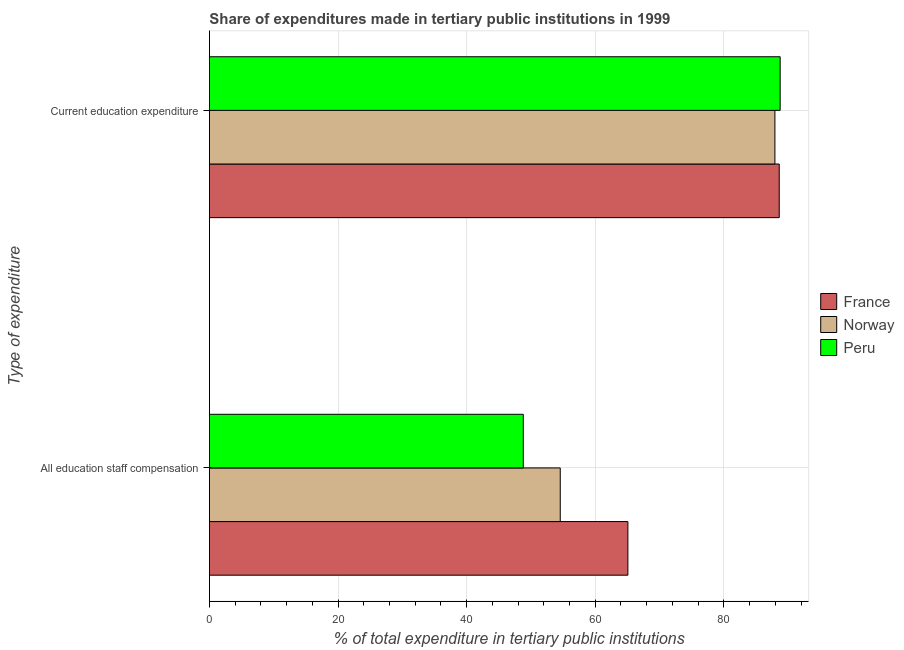Are the number of bars per tick equal to the number of legend labels?
Offer a very short reply. Yes. How many bars are there on the 1st tick from the top?
Provide a short and direct response. 3. What is the label of the 2nd group of bars from the top?
Provide a succinct answer. All education staff compensation. What is the expenditure in staff compensation in Norway?
Ensure brevity in your answer.  54.56. Across all countries, what is the maximum expenditure in education?
Your response must be concise. 88.76. Across all countries, what is the minimum expenditure in education?
Make the answer very short. 87.94. In which country was the expenditure in staff compensation maximum?
Your response must be concise. France. What is the total expenditure in education in the graph?
Your answer should be compact. 265.3. What is the difference between the expenditure in staff compensation in Norway and that in France?
Make the answer very short. -10.52. What is the difference between the expenditure in education in France and the expenditure in staff compensation in Norway?
Offer a very short reply. 34.05. What is the average expenditure in education per country?
Provide a short and direct response. 88.43. What is the difference between the expenditure in staff compensation and expenditure in education in Norway?
Provide a short and direct response. -33.38. What is the ratio of the expenditure in staff compensation in Norway to that in France?
Offer a terse response. 0.84. Is the expenditure in staff compensation in France less than that in Peru?
Provide a short and direct response. No. What does the 2nd bar from the top in All education staff compensation represents?
Offer a terse response. Norway. What does the 1st bar from the bottom in Current education expenditure represents?
Offer a terse response. France. How many bars are there?
Your response must be concise. 6. What is the difference between two consecutive major ticks on the X-axis?
Ensure brevity in your answer.  20. Are the values on the major ticks of X-axis written in scientific E-notation?
Provide a short and direct response. No. Does the graph contain any zero values?
Your answer should be very brief. No. Does the graph contain grids?
Your answer should be compact. Yes. Where does the legend appear in the graph?
Provide a short and direct response. Center right. How many legend labels are there?
Your response must be concise. 3. How are the legend labels stacked?
Ensure brevity in your answer.  Vertical. What is the title of the graph?
Your answer should be very brief. Share of expenditures made in tertiary public institutions in 1999. What is the label or title of the X-axis?
Offer a terse response. % of total expenditure in tertiary public institutions. What is the label or title of the Y-axis?
Keep it short and to the point. Type of expenditure. What is the % of total expenditure in tertiary public institutions of France in All education staff compensation?
Your answer should be very brief. 65.08. What is the % of total expenditure in tertiary public institutions of Norway in All education staff compensation?
Make the answer very short. 54.56. What is the % of total expenditure in tertiary public institutions in Peru in All education staff compensation?
Provide a succinct answer. 48.81. What is the % of total expenditure in tertiary public institutions in France in Current education expenditure?
Provide a succinct answer. 88.61. What is the % of total expenditure in tertiary public institutions in Norway in Current education expenditure?
Give a very brief answer. 87.94. What is the % of total expenditure in tertiary public institutions of Peru in Current education expenditure?
Your answer should be compact. 88.76. Across all Type of expenditure, what is the maximum % of total expenditure in tertiary public institutions of France?
Your answer should be very brief. 88.61. Across all Type of expenditure, what is the maximum % of total expenditure in tertiary public institutions in Norway?
Ensure brevity in your answer.  87.94. Across all Type of expenditure, what is the maximum % of total expenditure in tertiary public institutions in Peru?
Your answer should be compact. 88.76. Across all Type of expenditure, what is the minimum % of total expenditure in tertiary public institutions of France?
Give a very brief answer. 65.08. Across all Type of expenditure, what is the minimum % of total expenditure in tertiary public institutions of Norway?
Your answer should be compact. 54.56. Across all Type of expenditure, what is the minimum % of total expenditure in tertiary public institutions of Peru?
Provide a succinct answer. 48.81. What is the total % of total expenditure in tertiary public institutions in France in the graph?
Your response must be concise. 153.69. What is the total % of total expenditure in tertiary public institutions of Norway in the graph?
Make the answer very short. 142.5. What is the total % of total expenditure in tertiary public institutions in Peru in the graph?
Offer a very short reply. 137.57. What is the difference between the % of total expenditure in tertiary public institutions of France in All education staff compensation and that in Current education expenditure?
Make the answer very short. -23.53. What is the difference between the % of total expenditure in tertiary public institutions of Norway in All education staff compensation and that in Current education expenditure?
Your answer should be compact. -33.38. What is the difference between the % of total expenditure in tertiary public institutions of Peru in All education staff compensation and that in Current education expenditure?
Provide a short and direct response. -39.94. What is the difference between the % of total expenditure in tertiary public institutions of France in All education staff compensation and the % of total expenditure in tertiary public institutions of Norway in Current education expenditure?
Your response must be concise. -22.86. What is the difference between the % of total expenditure in tertiary public institutions of France in All education staff compensation and the % of total expenditure in tertiary public institutions of Peru in Current education expenditure?
Provide a succinct answer. -23.68. What is the difference between the % of total expenditure in tertiary public institutions of Norway in All education staff compensation and the % of total expenditure in tertiary public institutions of Peru in Current education expenditure?
Your response must be concise. -34.2. What is the average % of total expenditure in tertiary public institutions of France per Type of expenditure?
Your response must be concise. 76.84. What is the average % of total expenditure in tertiary public institutions in Norway per Type of expenditure?
Give a very brief answer. 71.25. What is the average % of total expenditure in tertiary public institutions of Peru per Type of expenditure?
Give a very brief answer. 68.78. What is the difference between the % of total expenditure in tertiary public institutions in France and % of total expenditure in tertiary public institutions in Norway in All education staff compensation?
Offer a terse response. 10.52. What is the difference between the % of total expenditure in tertiary public institutions of France and % of total expenditure in tertiary public institutions of Peru in All education staff compensation?
Provide a succinct answer. 16.27. What is the difference between the % of total expenditure in tertiary public institutions of Norway and % of total expenditure in tertiary public institutions of Peru in All education staff compensation?
Make the answer very short. 5.75. What is the difference between the % of total expenditure in tertiary public institutions in France and % of total expenditure in tertiary public institutions in Norway in Current education expenditure?
Give a very brief answer. 0.67. What is the difference between the % of total expenditure in tertiary public institutions of France and % of total expenditure in tertiary public institutions of Peru in Current education expenditure?
Provide a short and direct response. -0.14. What is the difference between the % of total expenditure in tertiary public institutions of Norway and % of total expenditure in tertiary public institutions of Peru in Current education expenditure?
Keep it short and to the point. -0.82. What is the ratio of the % of total expenditure in tertiary public institutions of France in All education staff compensation to that in Current education expenditure?
Your response must be concise. 0.73. What is the ratio of the % of total expenditure in tertiary public institutions in Norway in All education staff compensation to that in Current education expenditure?
Ensure brevity in your answer.  0.62. What is the ratio of the % of total expenditure in tertiary public institutions in Peru in All education staff compensation to that in Current education expenditure?
Offer a very short reply. 0.55. What is the difference between the highest and the second highest % of total expenditure in tertiary public institutions of France?
Offer a terse response. 23.53. What is the difference between the highest and the second highest % of total expenditure in tertiary public institutions in Norway?
Ensure brevity in your answer.  33.38. What is the difference between the highest and the second highest % of total expenditure in tertiary public institutions of Peru?
Ensure brevity in your answer.  39.94. What is the difference between the highest and the lowest % of total expenditure in tertiary public institutions in France?
Keep it short and to the point. 23.53. What is the difference between the highest and the lowest % of total expenditure in tertiary public institutions in Norway?
Your response must be concise. 33.38. What is the difference between the highest and the lowest % of total expenditure in tertiary public institutions in Peru?
Ensure brevity in your answer.  39.94. 